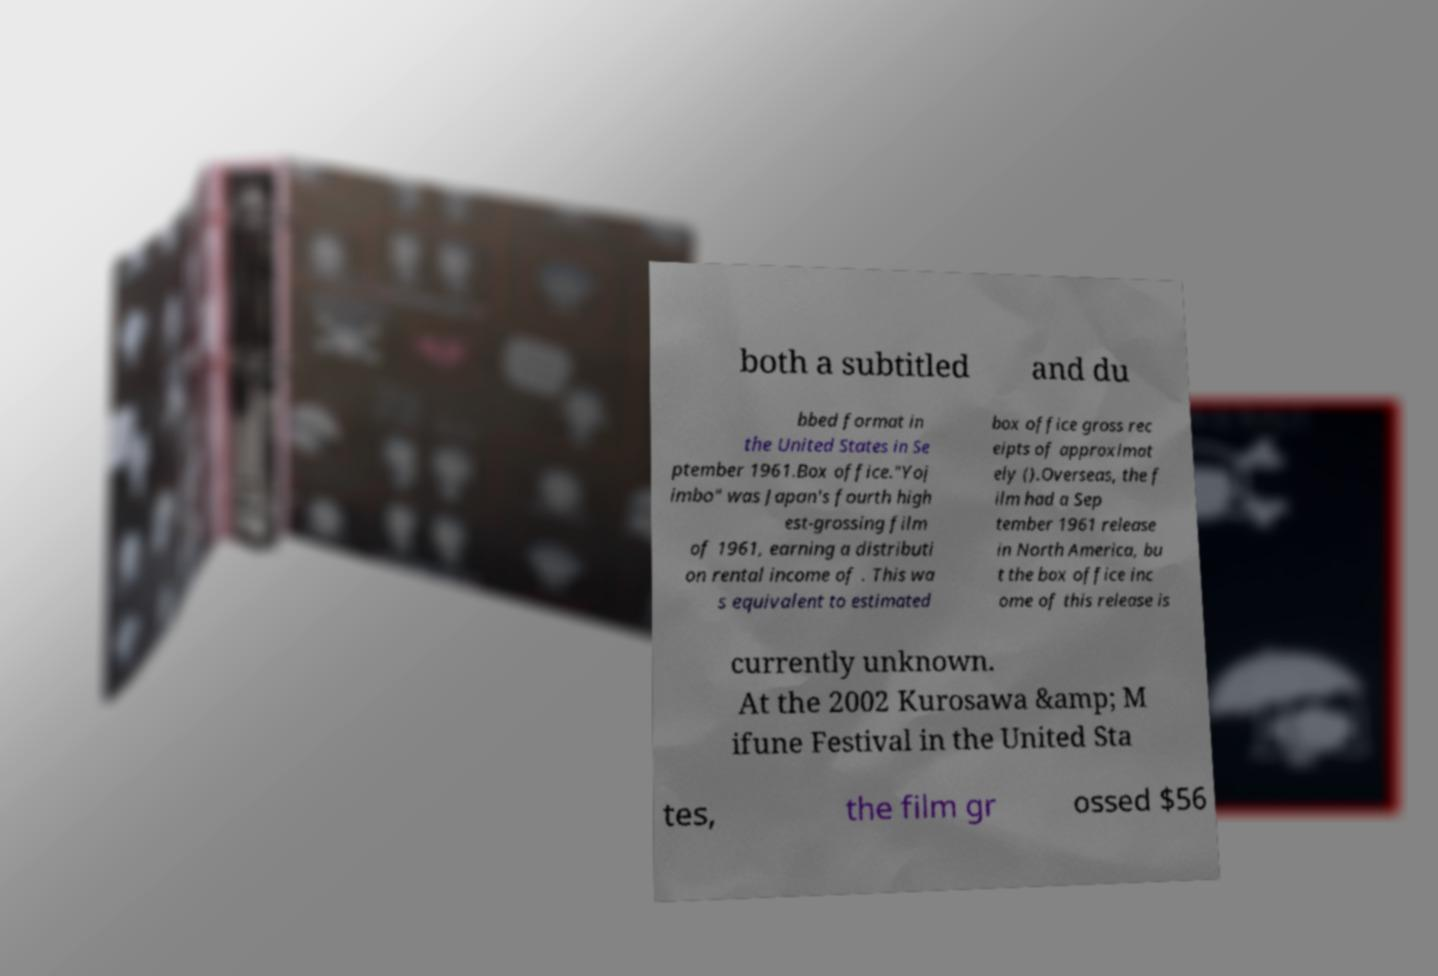Please identify and transcribe the text found in this image. both a subtitled and du bbed format in the United States in Se ptember 1961.Box office."Yoj imbo" was Japan's fourth high est-grossing film of 1961, earning a distributi on rental income of . This wa s equivalent to estimated box office gross rec eipts of approximat ely ().Overseas, the f ilm had a Sep tember 1961 release in North America, bu t the box office inc ome of this release is currently unknown. At the 2002 Kurosawa &amp; M ifune Festival in the United Sta tes, the film gr ossed $56 